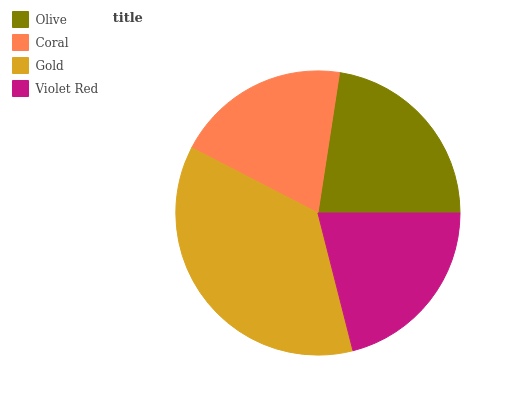Is Coral the minimum?
Answer yes or no. Yes. Is Gold the maximum?
Answer yes or no. Yes. Is Gold the minimum?
Answer yes or no. No. Is Coral the maximum?
Answer yes or no. No. Is Gold greater than Coral?
Answer yes or no. Yes. Is Coral less than Gold?
Answer yes or no. Yes. Is Coral greater than Gold?
Answer yes or no. No. Is Gold less than Coral?
Answer yes or no. No. Is Olive the high median?
Answer yes or no. Yes. Is Violet Red the low median?
Answer yes or no. Yes. Is Coral the high median?
Answer yes or no. No. Is Gold the low median?
Answer yes or no. No. 